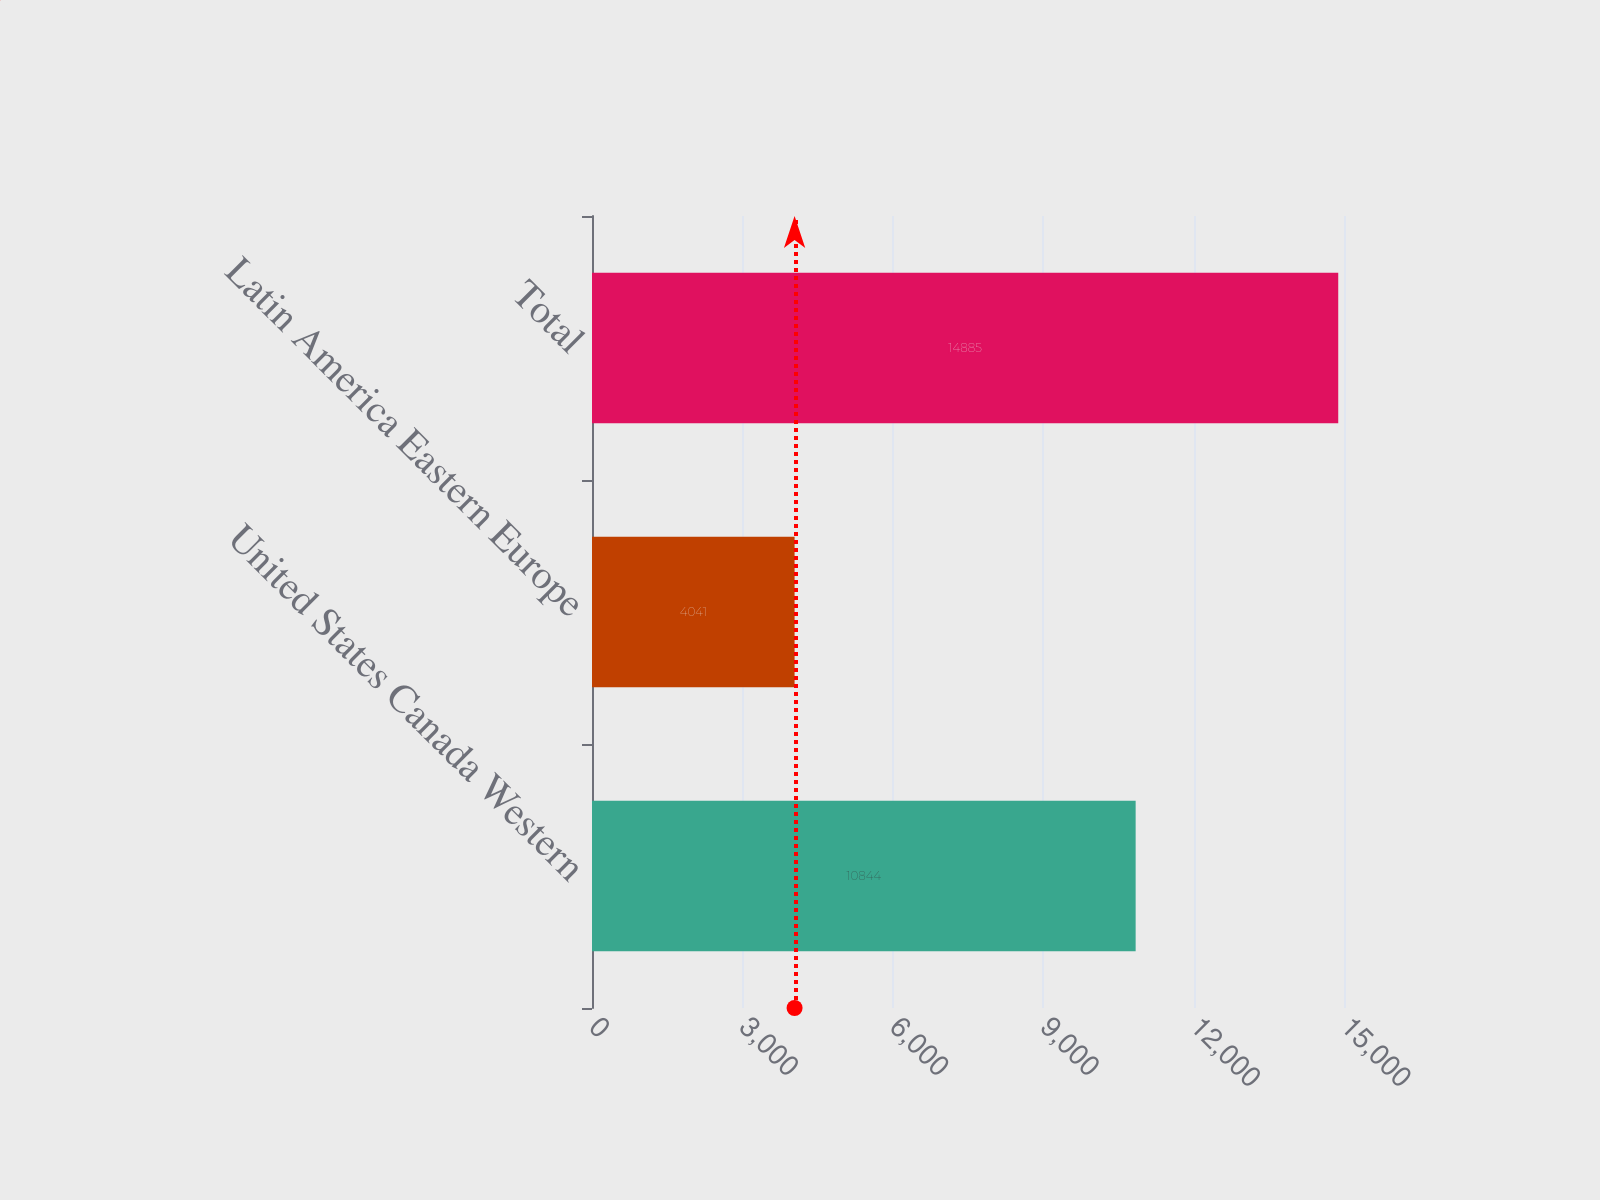<chart> <loc_0><loc_0><loc_500><loc_500><bar_chart><fcel>United States Canada Western<fcel>Latin America Eastern Europe<fcel>Total<nl><fcel>10844<fcel>4041<fcel>14885<nl></chart> 